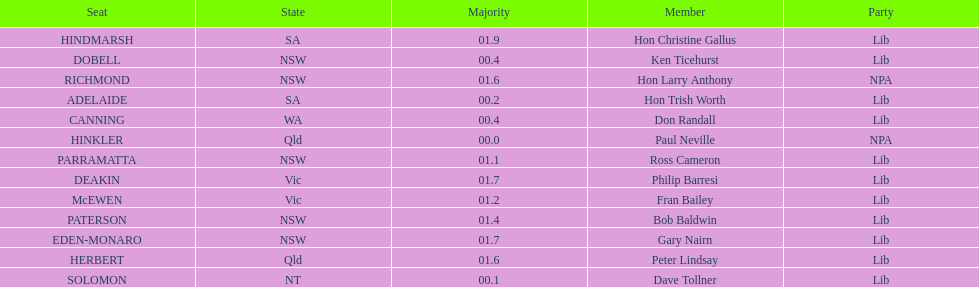How many states were represented in the seats? 6. Could you parse the entire table? {'header': ['Seat', 'State', 'Majority', 'Member', 'Party'], 'rows': [['HINDMARSH', 'SA', '01.9', 'Hon Christine Gallus', 'Lib'], ['DOBELL', 'NSW', '00.4', 'Ken Ticehurst', 'Lib'], ['RICHMOND', 'NSW', '01.6', 'Hon Larry Anthony', 'NPA'], ['ADELAIDE', 'SA', '00.2', 'Hon Trish Worth', 'Lib'], ['CANNING', 'WA', '00.4', 'Don Randall', 'Lib'], ['HINKLER', 'Qld', '00.0', 'Paul Neville', 'NPA'], ['PARRAMATTA', 'NSW', '01.1', 'Ross Cameron', 'Lib'], ['DEAKIN', 'Vic', '01.7', 'Philip Barresi', 'Lib'], ['McEWEN', 'Vic', '01.2', 'Fran Bailey', 'Lib'], ['PATERSON', 'NSW', '01.4', 'Bob Baldwin', 'Lib'], ['EDEN-MONARO', 'NSW', '01.7', 'Gary Nairn', 'Lib'], ['HERBERT', 'Qld', '01.6', 'Peter Lindsay', 'Lib'], ['SOLOMON', 'NT', '00.1', 'Dave Tollner', 'Lib']]} 